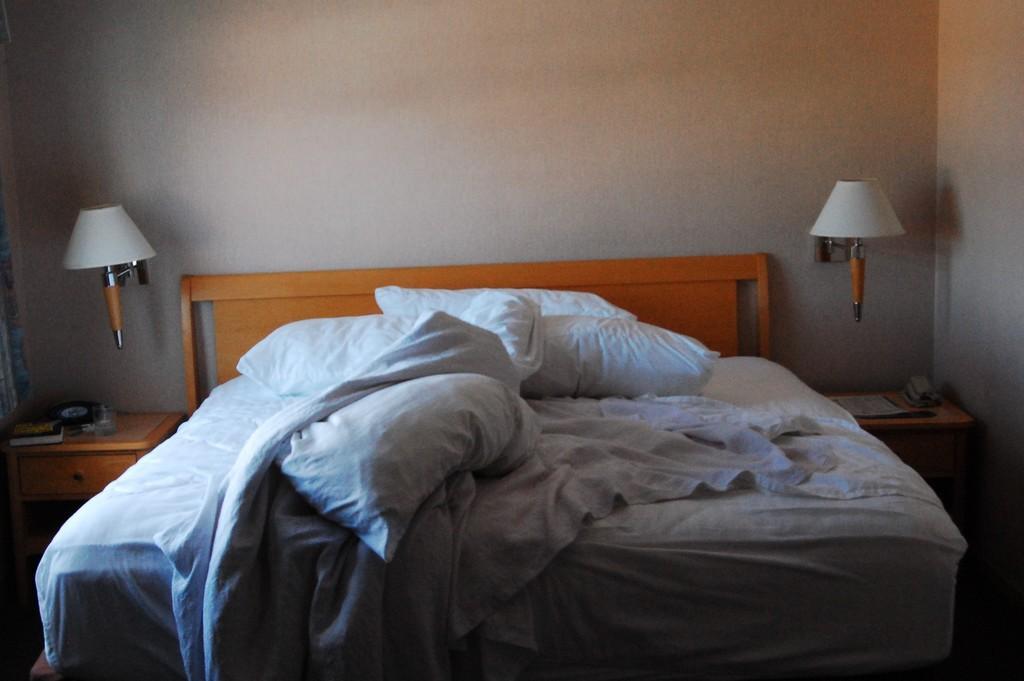Describe this image in one or two sentences. This picture is taken in a room, there is a bed in the center. On the bed there are white pillows and blanket. Towards left and right, there are lamps and tables. On the left table, there are books books and glass. Towards the right table, there are papers. In the background there is a wall. 